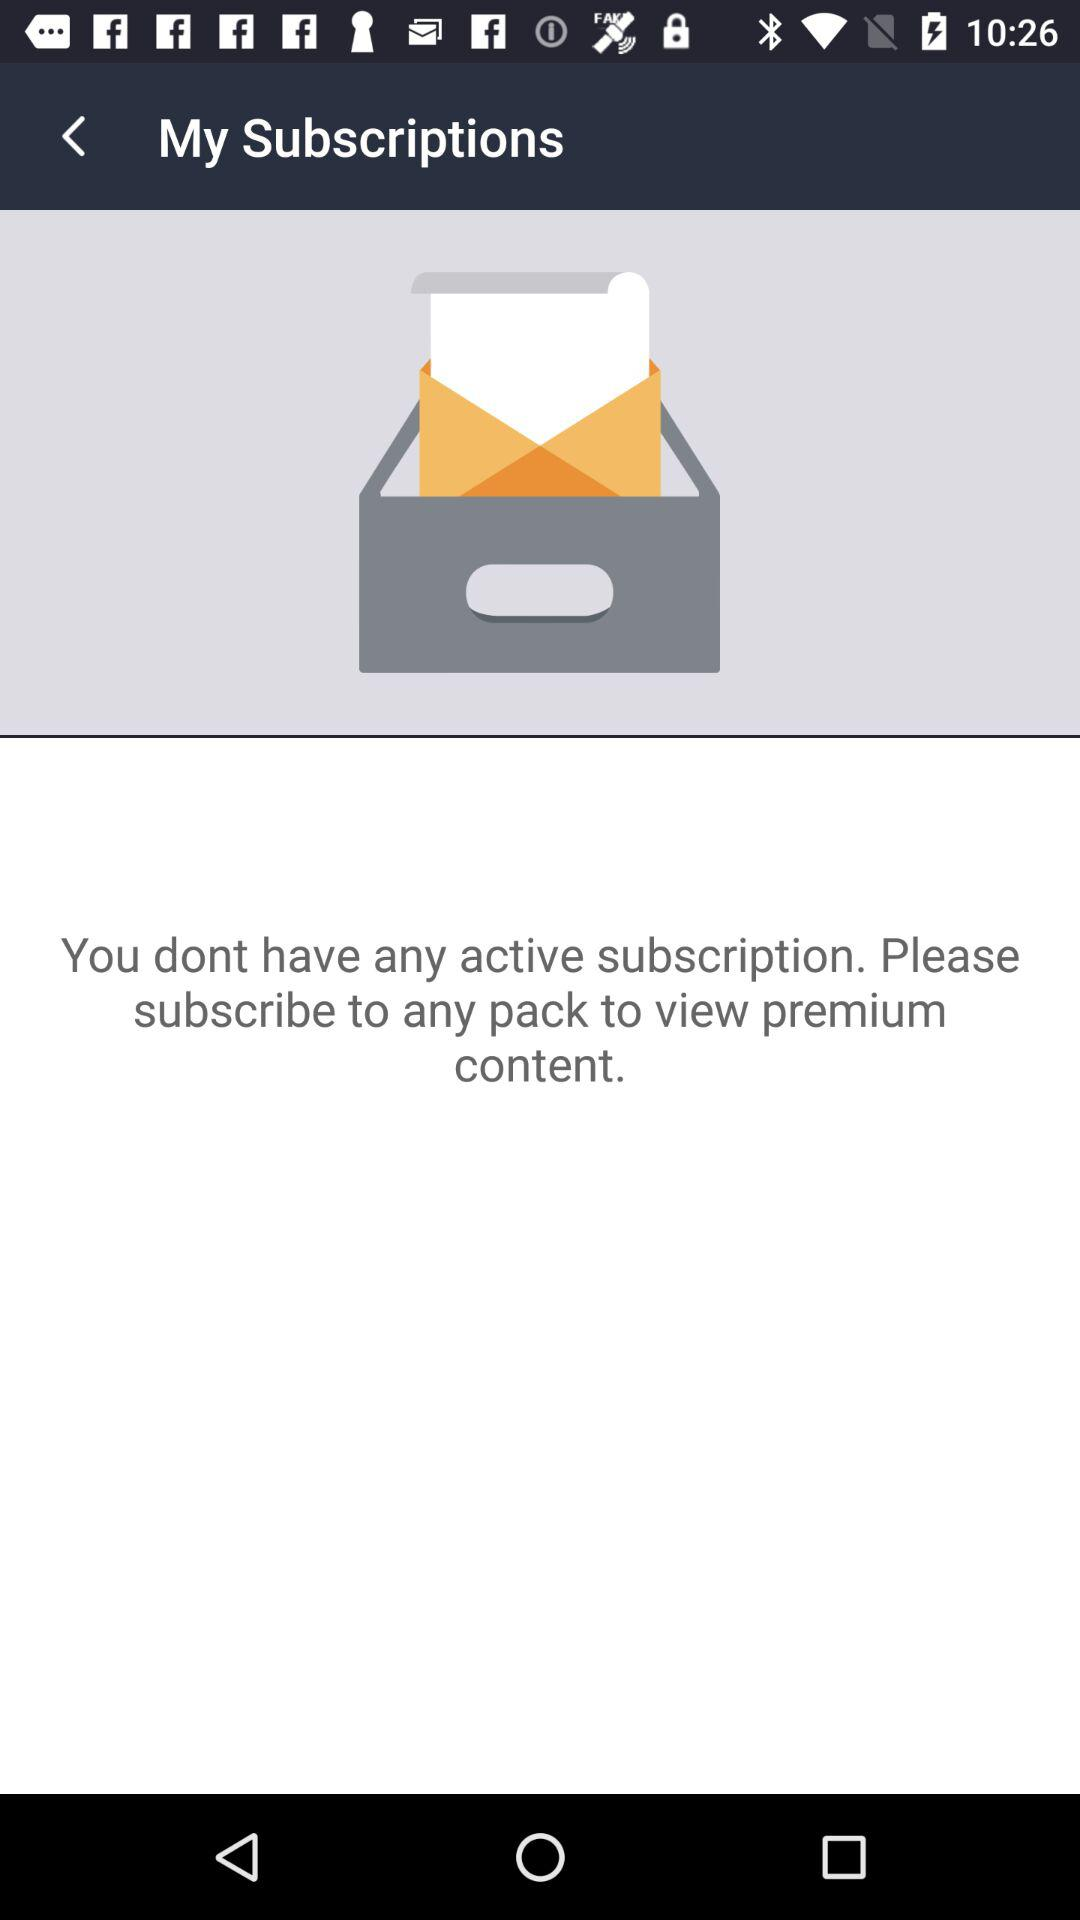How many active subscriptions do I have? Based on the notification displayed in the image which states, 'You dont have any active subscription. Please subscribe to any pack to view premium content.', it appears you do not have any active subscriptions at the moment. If this information is not accurate, please check your account details or contact customer service for assistance. 